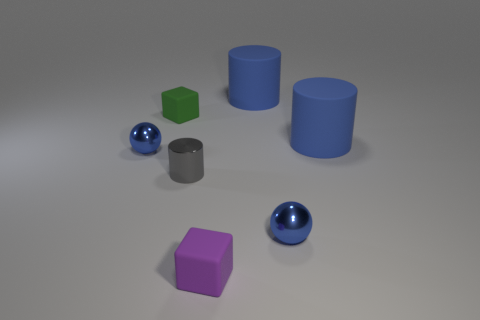How many things are either tiny blocks or tiny blue spheres that are to the right of the tiny purple object?
Provide a short and direct response. 3. What color is the metallic cylinder?
Your answer should be compact. Gray. What is the color of the small rubber block that is left of the gray metal cylinder?
Offer a very short reply. Green. What number of objects are in front of the small matte cube that is on the left side of the purple matte object?
Keep it short and to the point. 5. Does the gray shiny object have the same size as the rubber thing that is to the left of the gray object?
Keep it short and to the point. Yes. Is there a sphere that has the same size as the green matte cube?
Offer a terse response. Yes. How many objects are small blue metallic things or blue matte cylinders?
Offer a terse response. 4. There is a matte cylinder in front of the green cube; is it the same size as the blue sphere behind the small cylinder?
Make the answer very short. No. Is there a small gray shiny object of the same shape as the tiny purple matte thing?
Provide a succinct answer. No. Are there fewer small gray objects behind the tiny green cube than big purple metallic spheres?
Make the answer very short. No. 